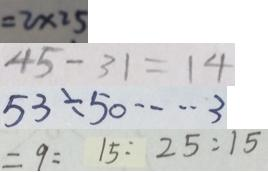Convert formula to latex. <formula><loc_0><loc_0><loc_500><loc_500>= 2 \times 2 5 
 4 5 - 3 1 = 1 4 
 5 3 \div 5 0 \cdots 3 
 = 9 = 1 5 : 2 5 : 1 5</formula> 